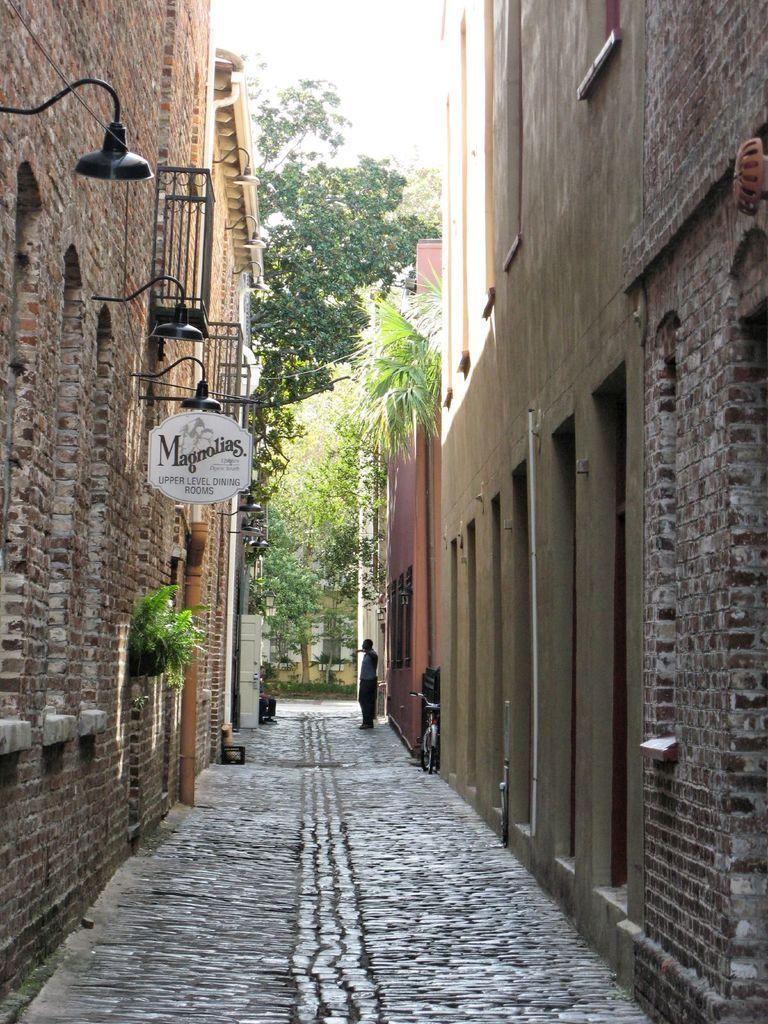Could you give a brief overview of what you see in this image? This image is taken outdoors. At the bottom of the image there is a floor. In the middle of the image there are a few trees and plants on the ground and a man is standing on a floor. A bicycle is parked on the floor. On the left and right sides of the image there are a few buildings with walls, windows, doors and roofs. There are a few lights and there is a board with a text on it. 